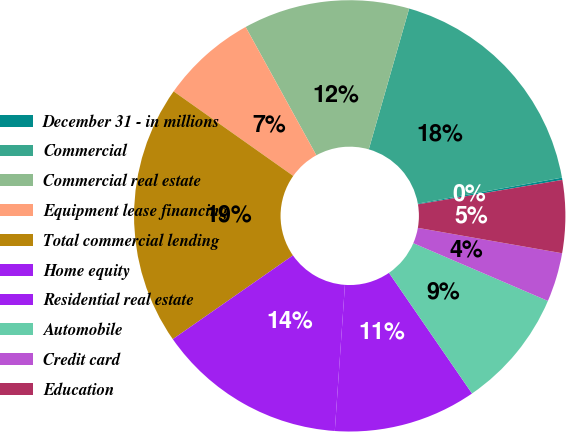<chart> <loc_0><loc_0><loc_500><loc_500><pie_chart><fcel>December 31 - in millions<fcel>Commercial<fcel>Commercial real estate<fcel>Equipment lease financing<fcel>Total commercial lending<fcel>Home equity<fcel>Residential real estate<fcel>Automobile<fcel>Credit card<fcel>Education<nl><fcel>0.17%<fcel>17.72%<fcel>12.46%<fcel>7.19%<fcel>19.48%<fcel>14.21%<fcel>10.7%<fcel>8.95%<fcel>3.68%<fcel>5.44%<nl></chart> 